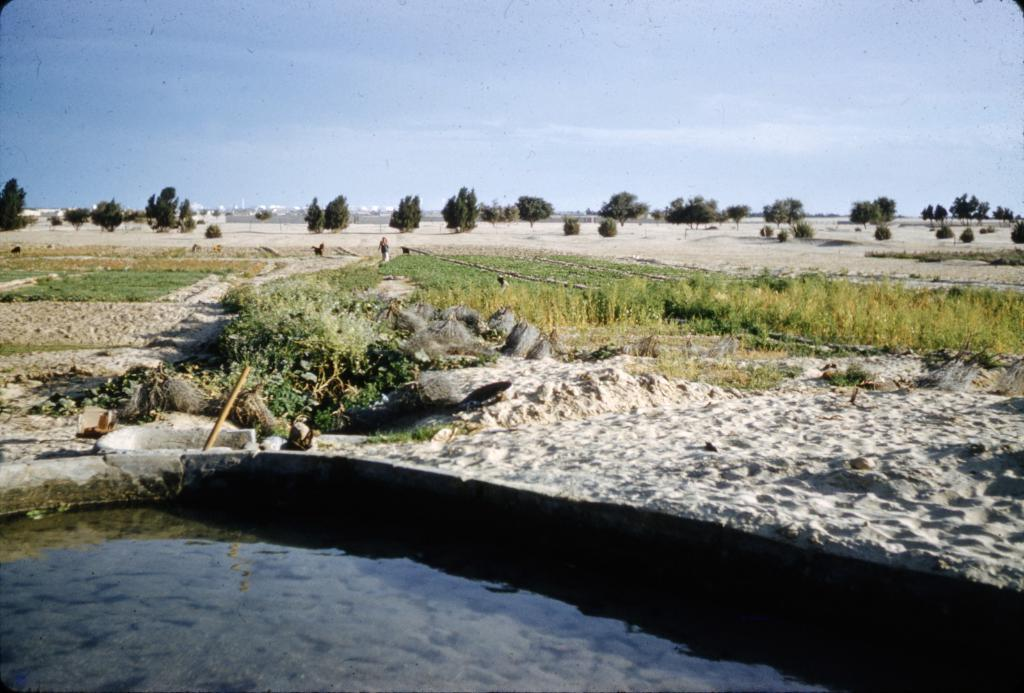What is present at the bottom side of the image? There is water at the bottom side of the image. What type of vegetation can be seen in the image? There are trees in the image. What type of terrain is visible in the image? There is grassland in the image. What is visible at the top side of the image? The sky is visible at the top side of the image. Can you see any elbows in the image? There are no elbows present in the image; it features water, trees, grassland, and sky. Are there any insects visible in the image? There is no mention of insects in the provided facts, so we cannot determine if any are present in the image. 